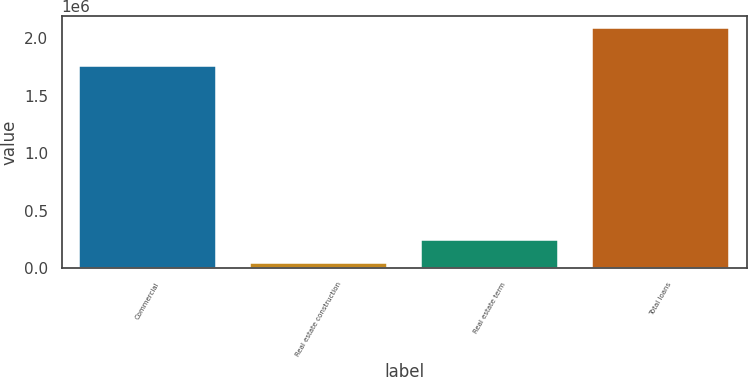Convert chart. <chart><loc_0><loc_0><loc_500><loc_500><bar_chart><fcel>Commercial<fcel>Real estate construction<fcel>Real estate term<fcel>Total loans<nl><fcel>1.75618e+06<fcel>43178<fcel>247468<fcel>2.08608e+06<nl></chart> 